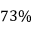<formula> <loc_0><loc_0><loc_500><loc_500>7 3 \%</formula> 